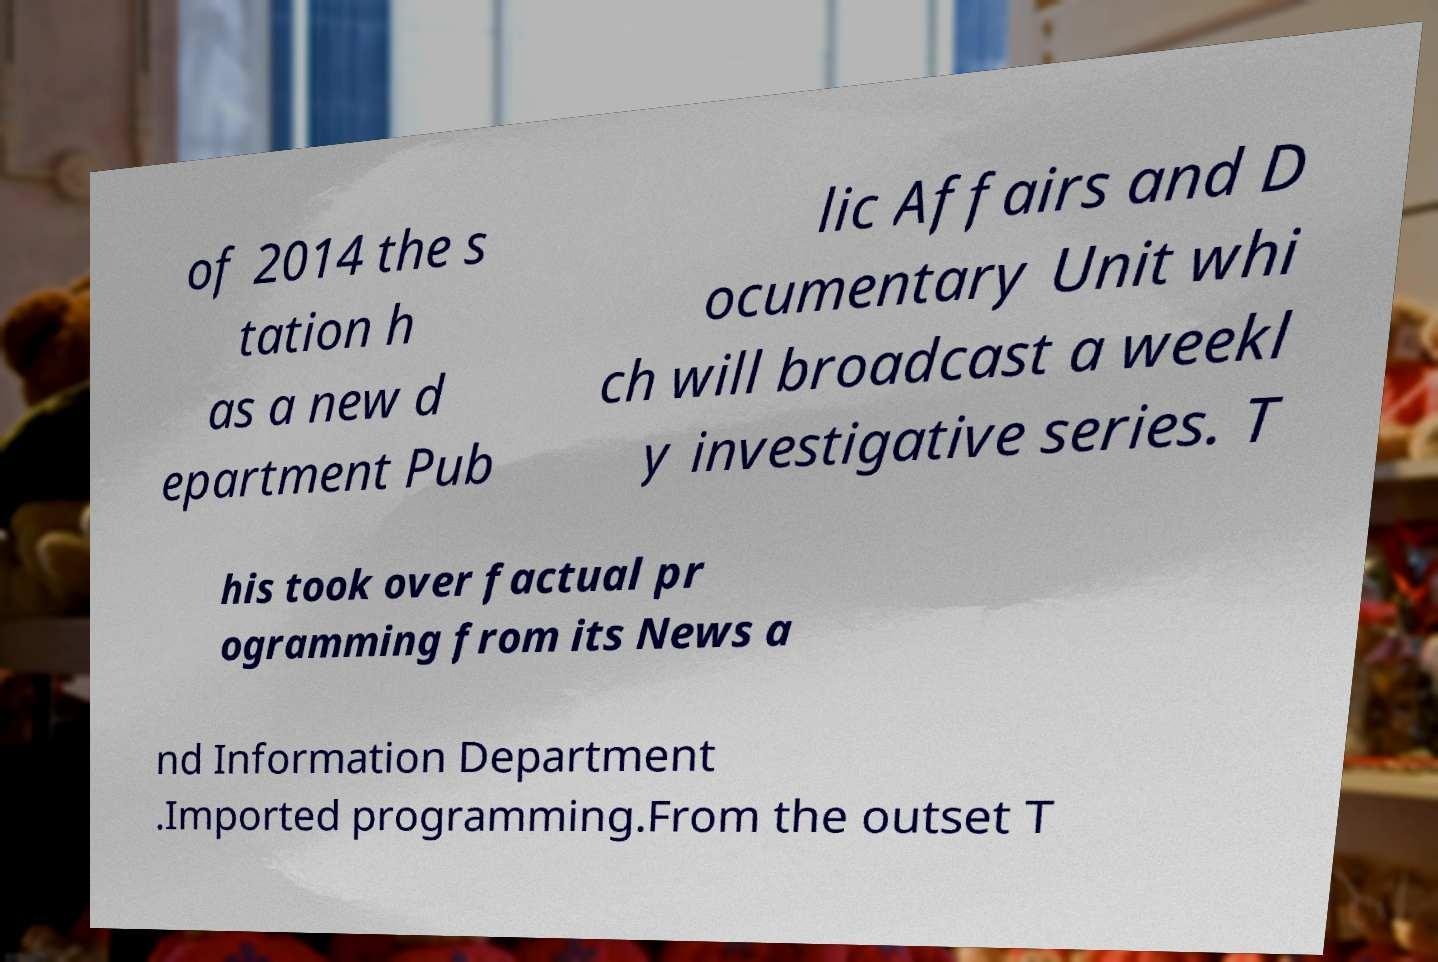Can you read and provide the text displayed in the image?This photo seems to have some interesting text. Can you extract and type it out for me? of 2014 the s tation h as a new d epartment Pub lic Affairs and D ocumentary Unit whi ch will broadcast a weekl y investigative series. T his took over factual pr ogramming from its News a nd Information Department .Imported programming.From the outset T 